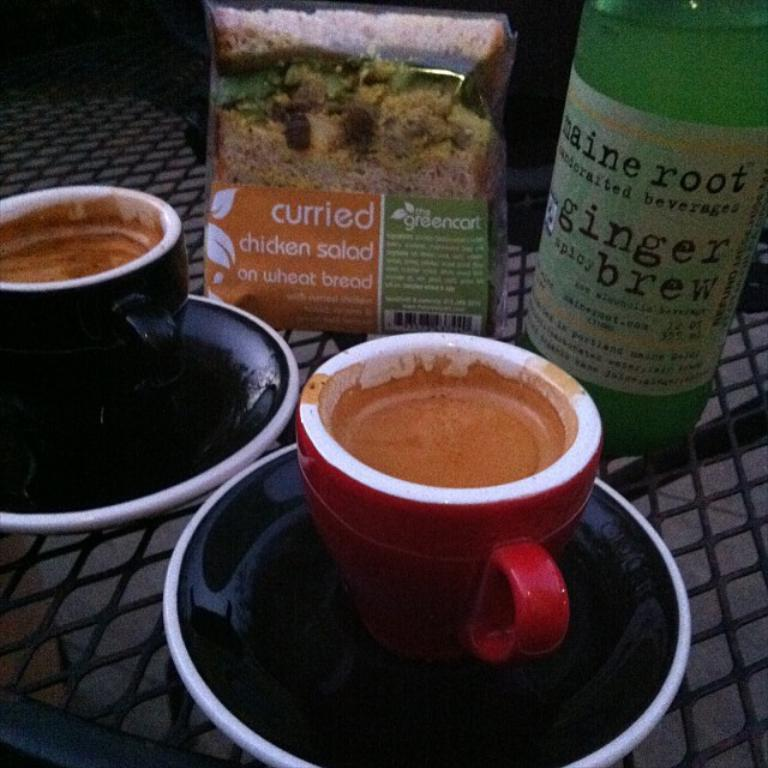What objects are filled with something in the image? There are cups filled with something in the image. How are the cups arranged in the image? The cups are on a saucer. What other items can be seen on the table in the image? There is a bottle and a packet present on the table. What book is being pushed across the table in the image? There is no book present in the image, and no objects are being pushed across the table. 